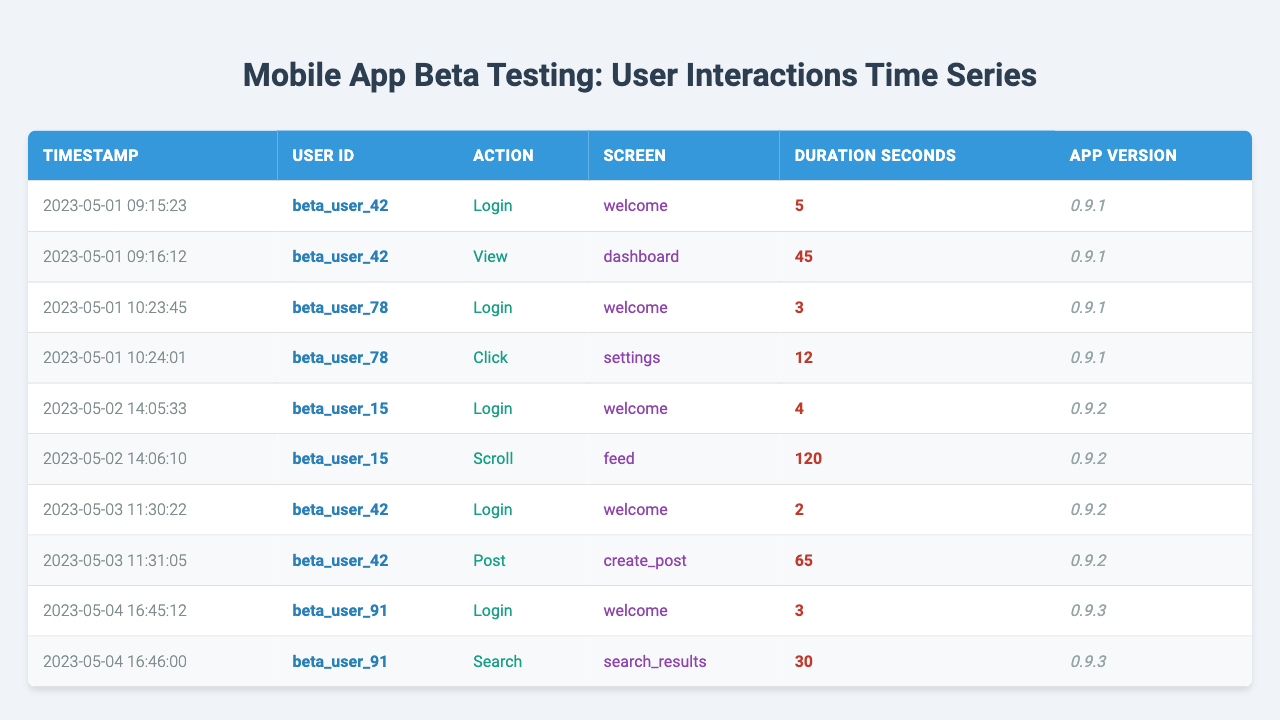What action did beta_user_42 perform at 09:16:12 on May 1, 2023? According to the table, at the specified timestamp, beta_user_42 performed the action "view" on the "dashboard" screen.
Answer: view How many seconds did beta_user_15 spend scrolling through the feed on May 2, 2023? The table indicates that beta_user_15 spent 120 seconds scrolling on the feed.
Answer: 120 seconds Did beta_user_91 perform a search action? Yes, the table shows that at 16:46:00 on May 4, 2023, beta_user_91 performed an action of type "search".
Answer: Yes What is the total duration of interactions for beta_user_42 across all entries? Looking at the entries for beta_user_42, the durations are 5, 45, 2, and 65 seconds. Summing them gives: 5 + 45 + 2 + 65 = 117 seconds.
Answer: 117 seconds Which user had the shortest login duration, and what was that duration? The login durations from the table are: beta_user_42 (5 seconds), beta_user_78 (3 seconds), beta_user_15 (4 seconds), and beta_user_91 (3 seconds). Both beta_user_78 and beta_user_91 had the shortest duration at 3 seconds.
Answer: beta_user_78 and beta_user_91, 3 seconds What was the average time spent by beta_user_15 across their actions? Beta_user_15 had 2 actions with durations of 4 seconds and 120 seconds. Calculating the average: (4 + 120) / 2 = 62 seconds.
Answer: 62 seconds How many unique users interacted with the app according to the table? The users listed in the table are beta_user_42, beta_user_78, beta_user_15, and beta_user_91—totaling 4 unique users.
Answer: 4 unique users Which app version was used by beta_user_42 during their interactions? The table shows that beta_user_42 interacted with app version "0.9.1" on May 1 and "0.9.2" on May 3.
Answer: 0.9.1 and 0.9.2 What is the total amount of time spent on actions that involved a screen interaction by beta_user_42? For beta_user_42, the durations for actions other than login are 45 seconds (view) and 65 seconds (post), totaling: 45 + 65 = 110 seconds.
Answer: 110 seconds Was there any action recorded for beta_user_78 after their login? Yes, the table records an action of "click" on the "settings" screen by beta_user_78, following their login.
Answer: Yes Which screen did beta_user_15 interact with for the longest duration? Beta_user_15 spent 120 seconds scrolling through the "feed", which is the longest duration compared to their other action.
Answer: feed 